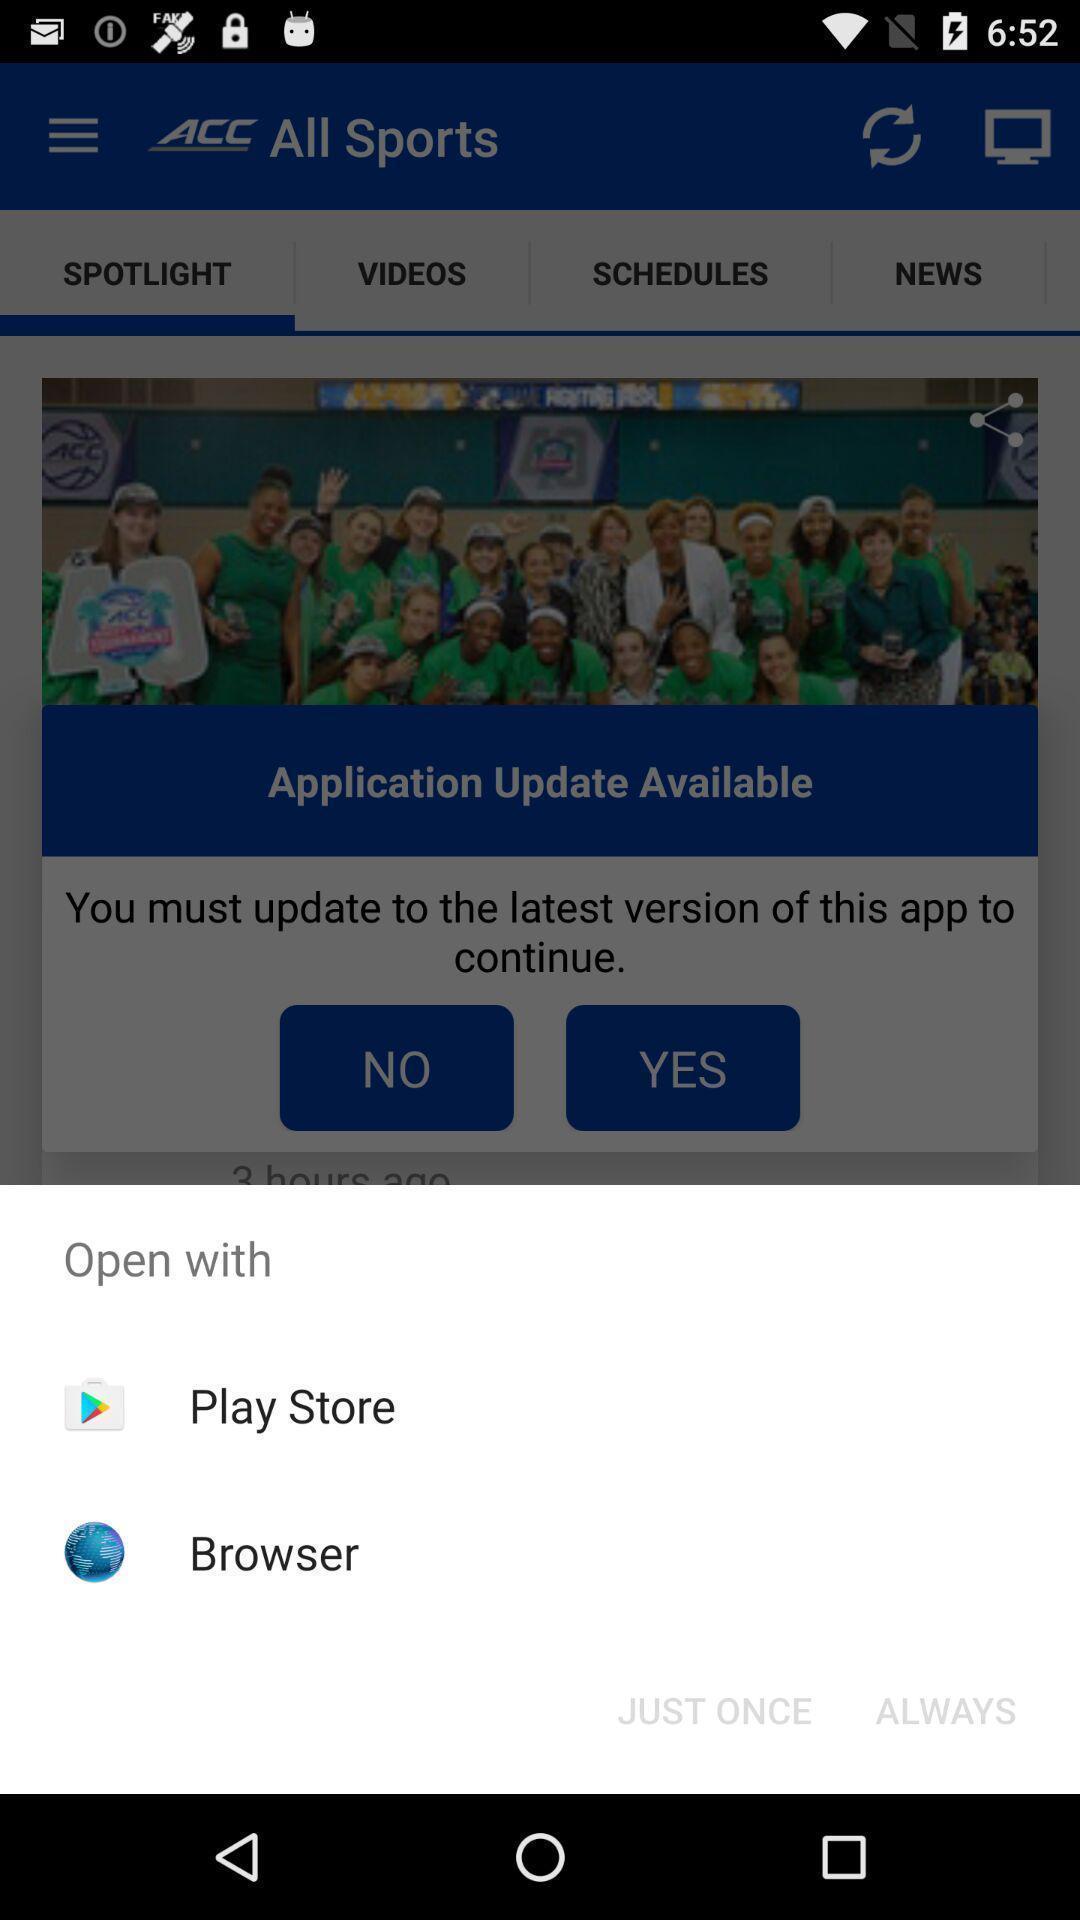Describe the content in this image. Pop-up shows to open with multiple applications. 